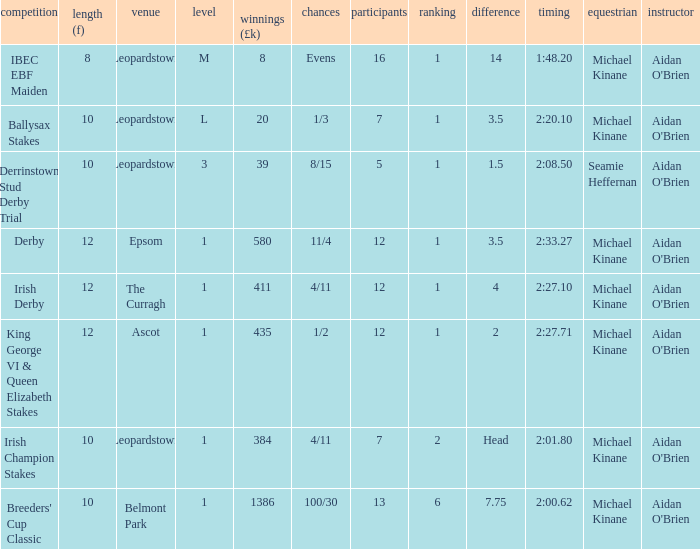Which Margin has a Dist (f) larger than 10, and a Race of king george vi & queen elizabeth stakes? 2.0. 